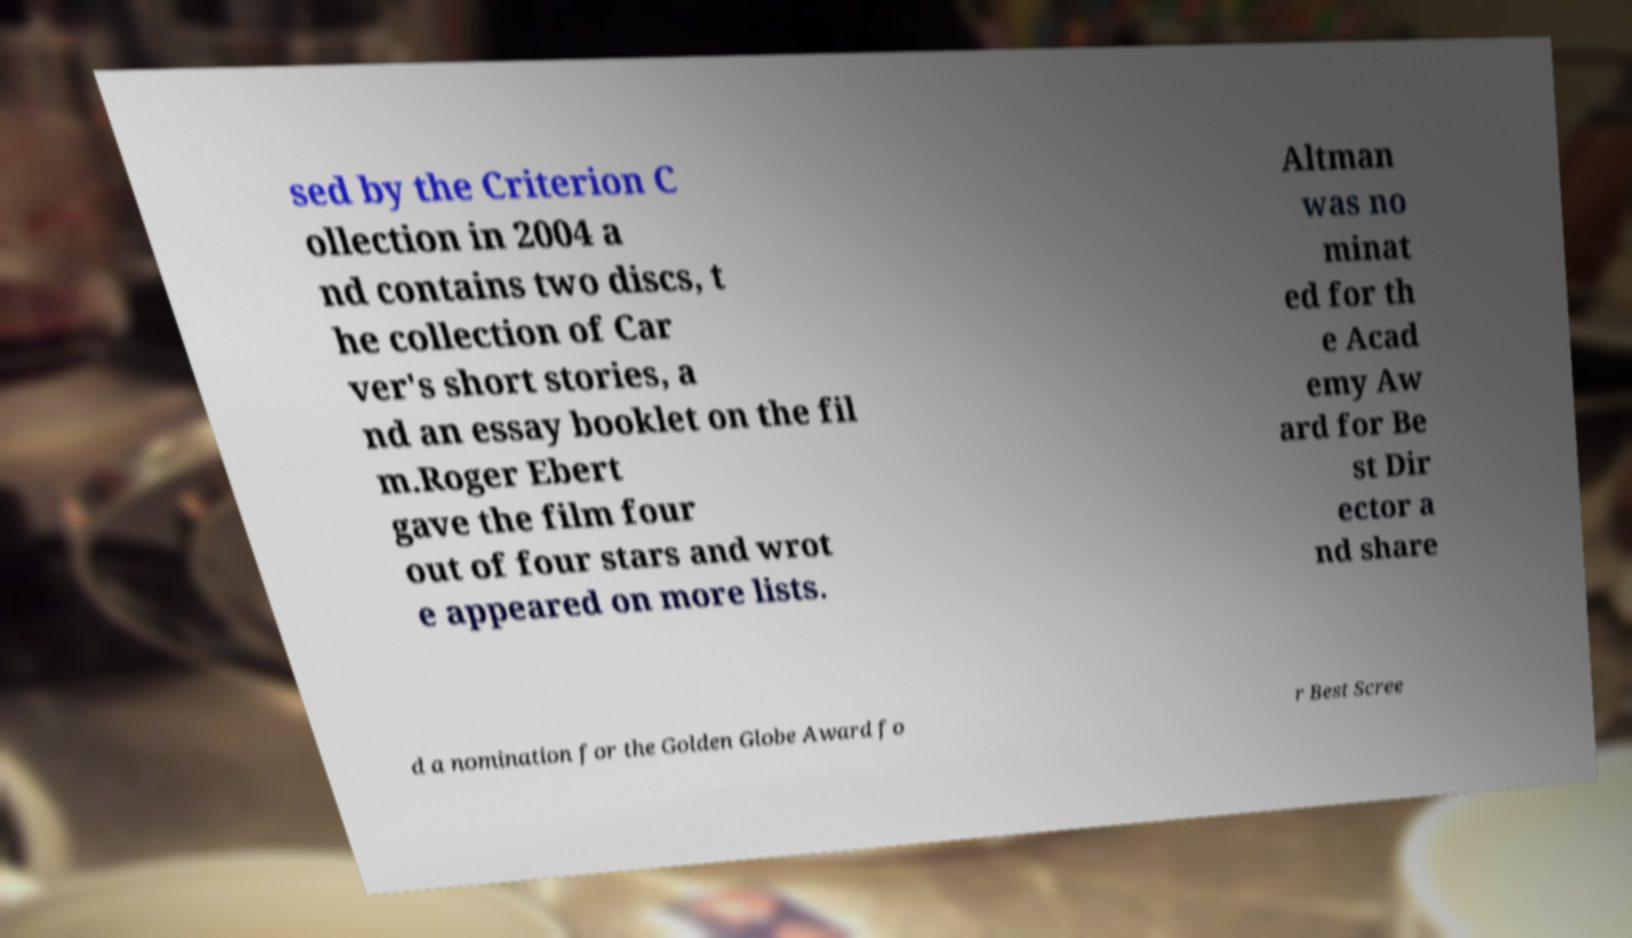Please read and relay the text visible in this image. What does it say? sed by the Criterion C ollection in 2004 a nd contains two discs, t he collection of Car ver's short stories, a nd an essay booklet on the fil m.Roger Ebert gave the film four out of four stars and wrot e appeared on more lists. Altman was no minat ed for th e Acad emy Aw ard for Be st Dir ector a nd share d a nomination for the Golden Globe Award fo r Best Scree 